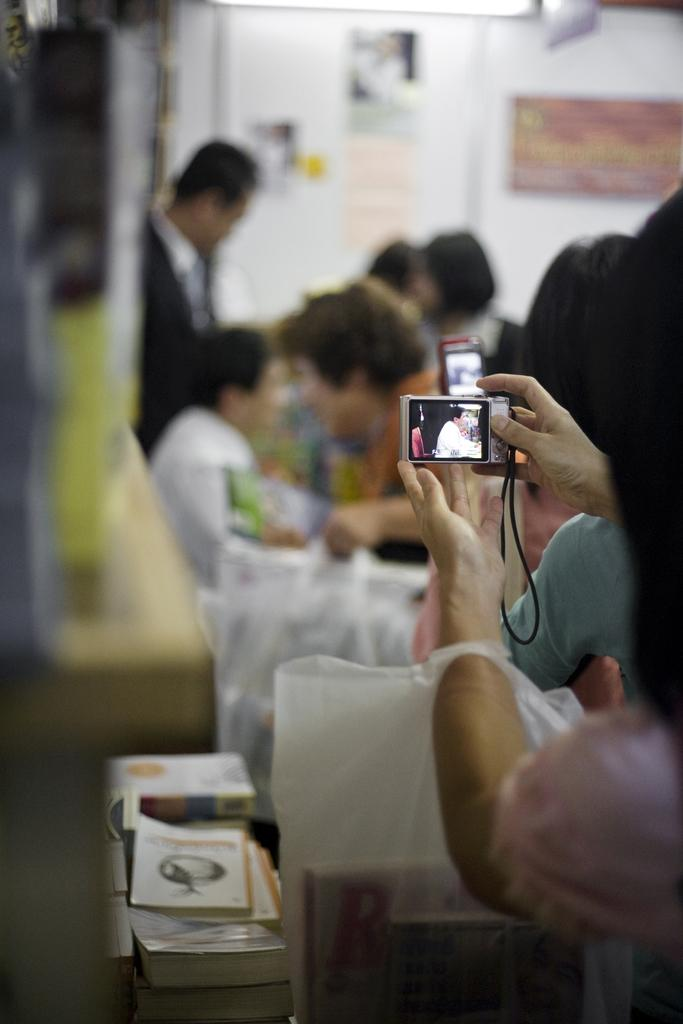How many people are in the image? There are people in the image, but the exact number is not specified. What is one person doing in the image? One person is holding a camera and a cover. What can be found beside the cover in the image? There are books beside the cover in the image. What can be seen in the background of the image? The background of the image is blurry, and there is a wall visible. What type of pain is the person experiencing in the image? There is no indication of pain in the image; the focus is on the person holding a camera and a cover. Is there a fire visible in the image? No, there is no fire present in the image. Can you describe the muscles of the person holding the camera? There is no information about the person's muscles in the image. 